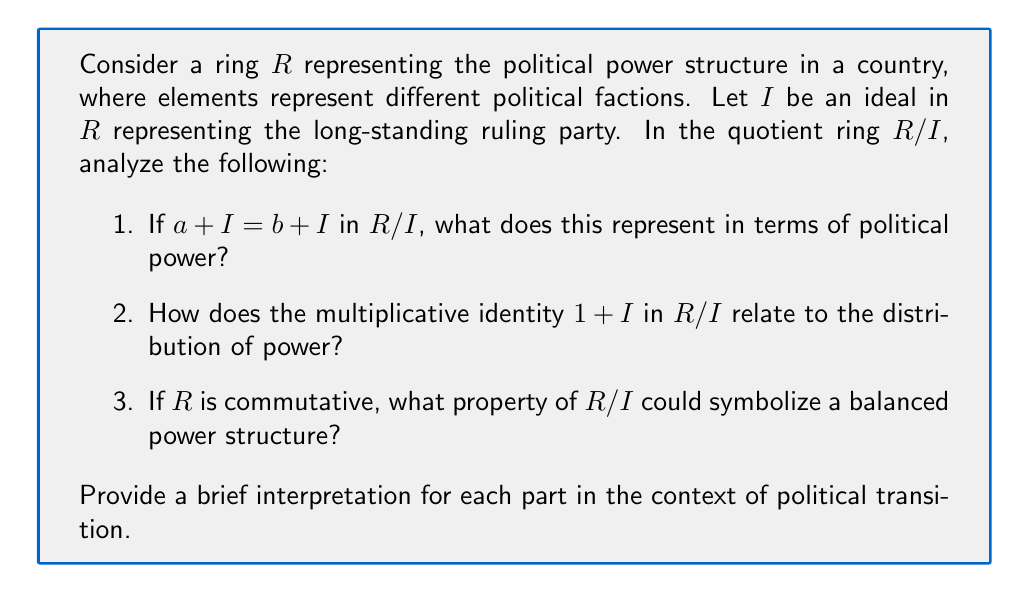Teach me how to tackle this problem. Let's analyze each part of the question step-by-step:

1. In the quotient ring $R/I$, $a + I = b + I$ means that $a$ and $b$ belong to the same coset. In political terms:
   - $a$ and $b$ represent different political factions
   - $I$ represents the influence of the ruling party
   - $a + I = b + I$ implies that factions $a$ and $b$ are equivalent modulo the ruling party's influence
   This could represent that despite apparent differences, these factions have similar effective power once the ruling party's influence is factored out.

2. The multiplicative identity $1 + I$ in $R/I$:
   - In ring theory, $1 + I$ acts as the multiplicative identity for all elements in $R/I$
   - Politically, this could symbolize a new "neutral" power base after the transition
   - $(a + I)(1 + I) = a + I$ for all $a + I \in R/I$ implies that this new power base doesn't change the relative influence of other factions

3. If $R$ is commutative, then $R/I$ is also commutative. In political terms:
   - Commutativity: $(a + I)(b + I) = (b + I)(a + I)$ for all $a + I, b + I \in R/I$
   - This could represent a balanced power structure where the order of interactions between political factions doesn't affect the outcome
   - It symbolizes a system where power is more evenly distributed, and no faction has a disproportionate influence over others

This analysis shows how the properties of a quotient ring can be used to model the transition of political power, representing the shift from a system dominated by a long-standing ruling party to a potentially more balanced structure.
Answer: 1. Equivalent political influence post-transition
2. New neutral power base
3. Balanced power structure 